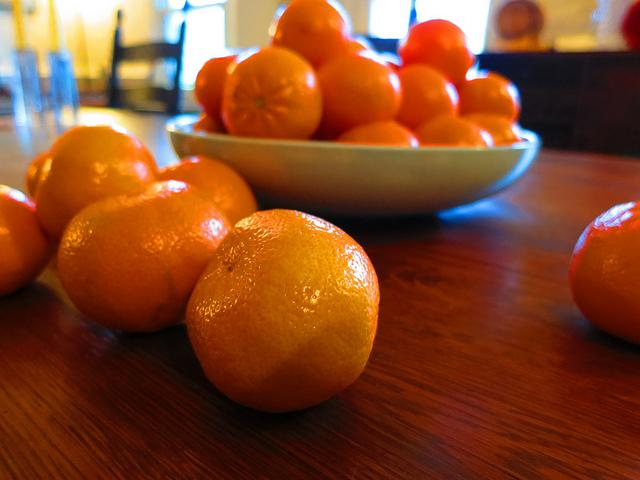What utensil is usually needed with this food? knife 